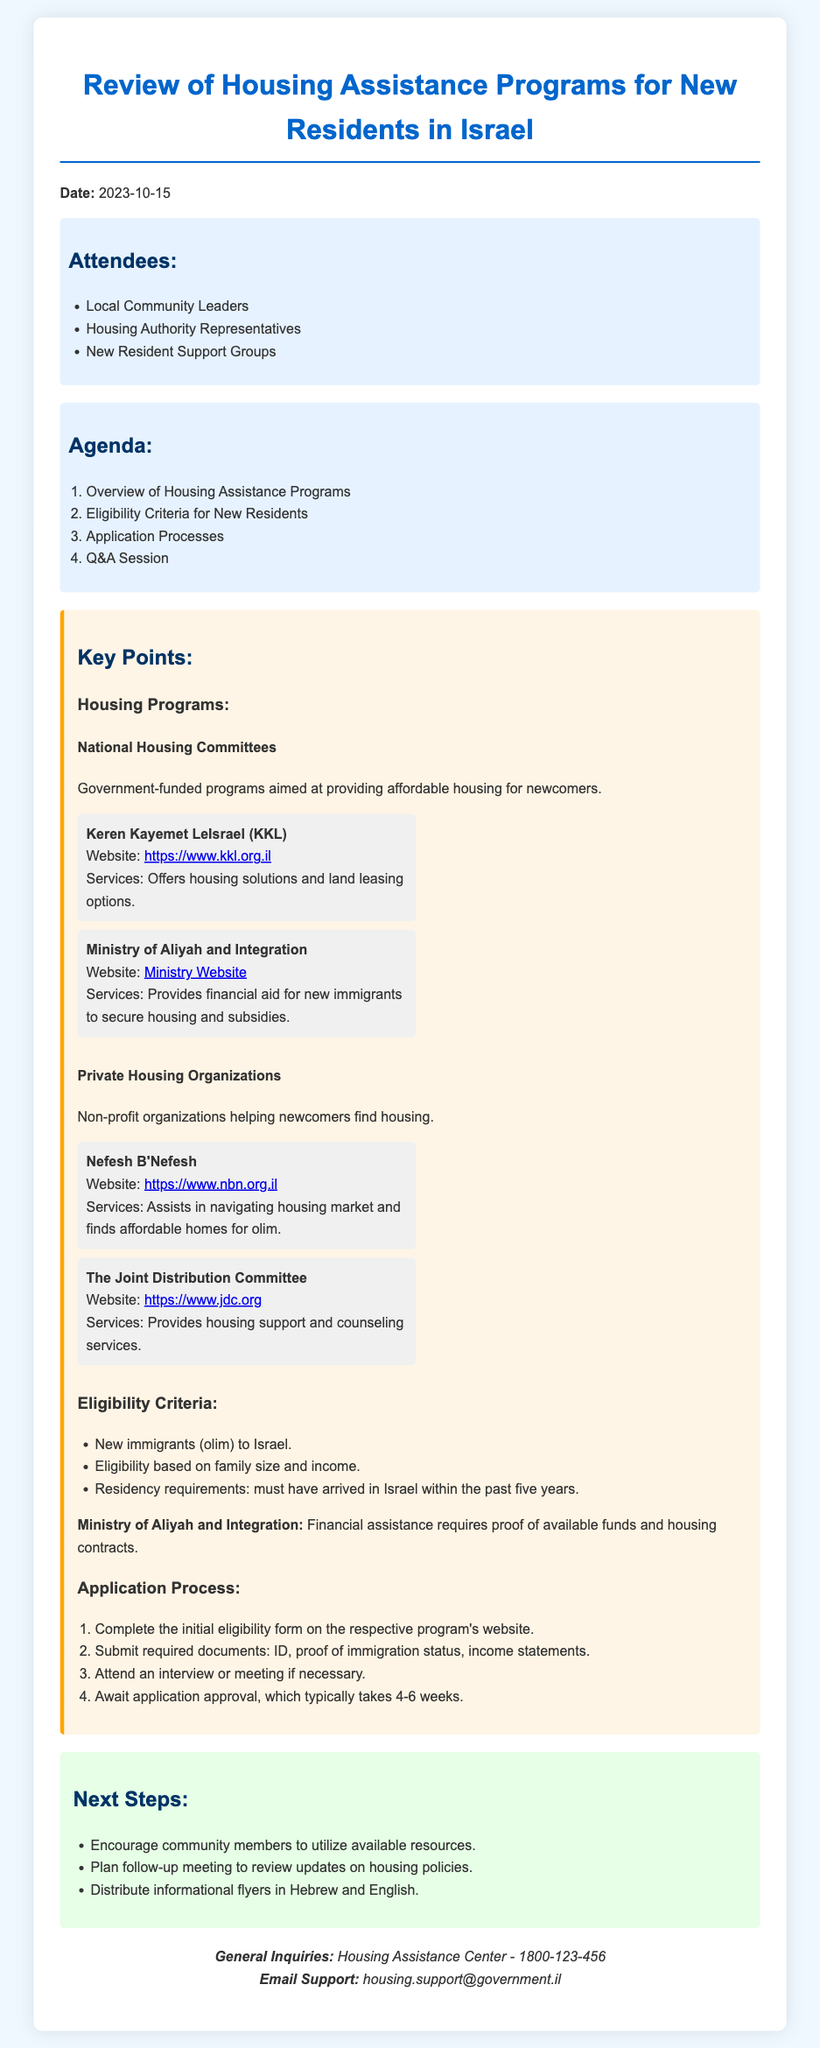What is the date of the meeting? The date of the meeting is explicitly mentioned in the document as "2023-10-15."
Answer: 2023-10-15 Who is one of the attendees? The document lists several attendees, including "Local Community Leaders."
Answer: Local Community Leaders What is one housing program mentioned? The document refers to "Keren Kayemet LeIsrael (KKL)" as one of the housing programs.
Answer: Keren Kayemet LeIsrael (KKL) What is the typical approval time for applications? The document states that application approval typically takes "4-6 weeks."
Answer: 4-6 weeks What is a requirement for eligibility? The document specifies "New immigrants (olim) to Israel" as part of the eligibility criteria.
Answer: New immigrants (olim) to Israel Which organization provides financial aid for new immigrants? The document mentions the "Ministry of Aliyah and Integration" as providing financial aid.
Answer: Ministry of Aliyah and Integration What must applicants submit with their application? The document outlines that applicants must submit "ID, proof of immigration status, income statements."
Answer: ID, proof of immigration status, income statements What should community members be encouraged to do? The document advises to "utilize available resources."
Answer: Utilize available resources 